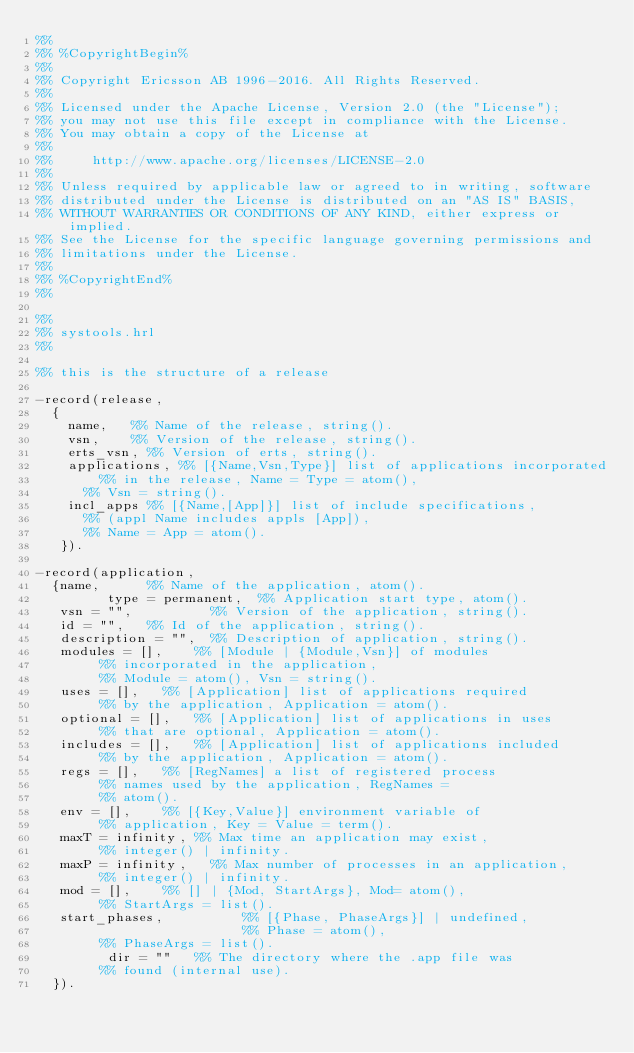<code> <loc_0><loc_0><loc_500><loc_500><_Erlang_>%%
%% %CopyrightBegin%
%% 
%% Copyright Ericsson AB 1996-2016. All Rights Reserved.
%% 
%% Licensed under the Apache License, Version 2.0 (the "License");
%% you may not use this file except in compliance with the License.
%% You may obtain a copy of the License at
%%
%%     http://www.apache.org/licenses/LICENSE-2.0
%%
%% Unless required by applicable law or agreed to in writing, software
%% distributed under the License is distributed on an "AS IS" BASIS,
%% WITHOUT WARRANTIES OR CONDITIONS OF ANY KIND, either express or implied.
%% See the License for the specific language governing permissions and
%% limitations under the License.
%% 
%% %CopyrightEnd%
%%

%%
%% systools.hrl
%%

%% this is the structure of a release

-record(release,
	{
	  name,		%% Name of the release, string().
	  vsn,		%% Version of the release, string().
	  erts_vsn,	%% Version of erts, string().
	  applications,	%% [{Name,Vsn,Type}] list of applications incorporated
	  		%% in the release, Name = Type = atom(), 
			%% Vsn = string().
	  incl_apps	%% [{Name,[App]}] list of include specifications,
			%% (appl Name includes appls [App]),
			%% Name = App = atom().
	 }).

-record(application, 
	{name,			%% Name of the application, atom().
         type = permanent,	%% Application start type, atom().
	 vsn = "",         	%% Version of the application, string().
	 id = "",		%% Id of the application, string().
	 description = "",	%% Description of application, string().
	 modules = [],		%% [Module | {Module,Vsn}] of modules 
				%% incorporated in the application, 
				%% Module = atom(), Vsn = string().
	 uses = [],		%% [Application] list of applications required
	 			%% by the application, Application = atom().
	 optional = [],		%% [Application] list of applications in uses
	 			%% that are optional, Application = atom().
	 includes = [],		%% [Application] list of applications included
	 			%% by the application, Application = atom().
	 regs = [],		%% [RegNames] a list of registered process 
				%% names used by the application, RegNames =
				%% atom().
	 env = [],		%% [{Key,Value}] environment variable of 
	 			%% application, Key = Value = term().
	 maxT = infinity,	%% Max time an application may exist, 
				%% integer() | infinity.
	 maxP = infinity,  	%% Max number of processes in an application,
	 			%% integer() | infinity.
	 mod = [],		%% [] | {Mod, StartArgs}, Mod= atom(), 
				%% StartArgs = list().
	 start_phases,          %% [{Phase, PhaseArgs}] | undefined,
	                        %% Phase = atom(),
				%% PhaseArgs = list().
         dir = ""		%% The directory where the .app file was 
				%% found (internal use).
	}).




</code> 